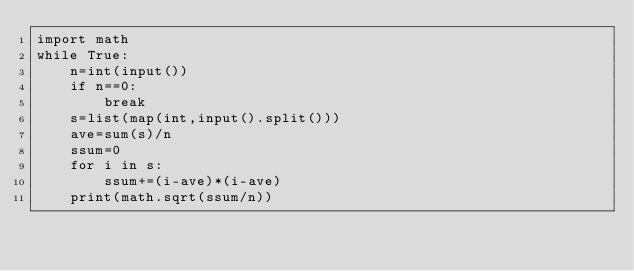Convert code to text. <code><loc_0><loc_0><loc_500><loc_500><_Python_>import math
while True:
    n=int(input())
    if n==0:
        break
    s=list(map(int,input().split()))
    ave=sum(s)/n
    ssum=0
    for i in s:
        ssum+=(i-ave)*(i-ave)
    print(math.sqrt(ssum/n))
</code> 